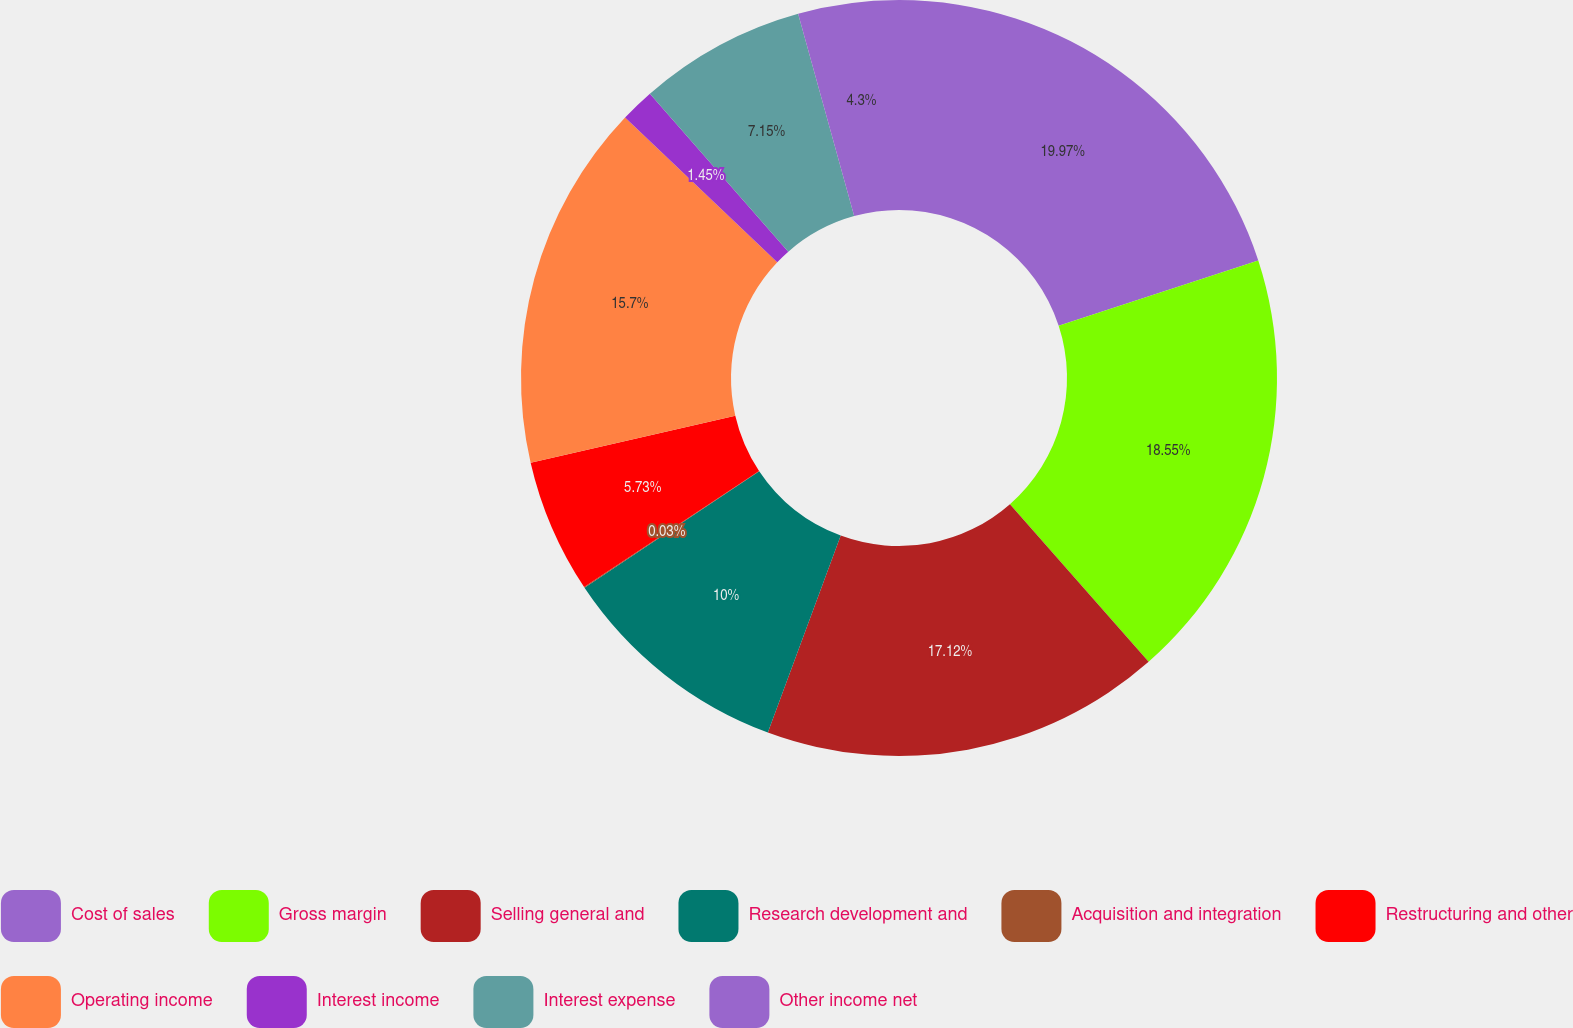Convert chart. <chart><loc_0><loc_0><loc_500><loc_500><pie_chart><fcel>Cost of sales<fcel>Gross margin<fcel>Selling general and<fcel>Research development and<fcel>Acquisition and integration<fcel>Restructuring and other<fcel>Operating income<fcel>Interest income<fcel>Interest expense<fcel>Other income net<nl><fcel>19.97%<fcel>18.55%<fcel>17.12%<fcel>10.0%<fcel>0.03%<fcel>5.73%<fcel>15.7%<fcel>1.45%<fcel>7.15%<fcel>4.3%<nl></chart> 